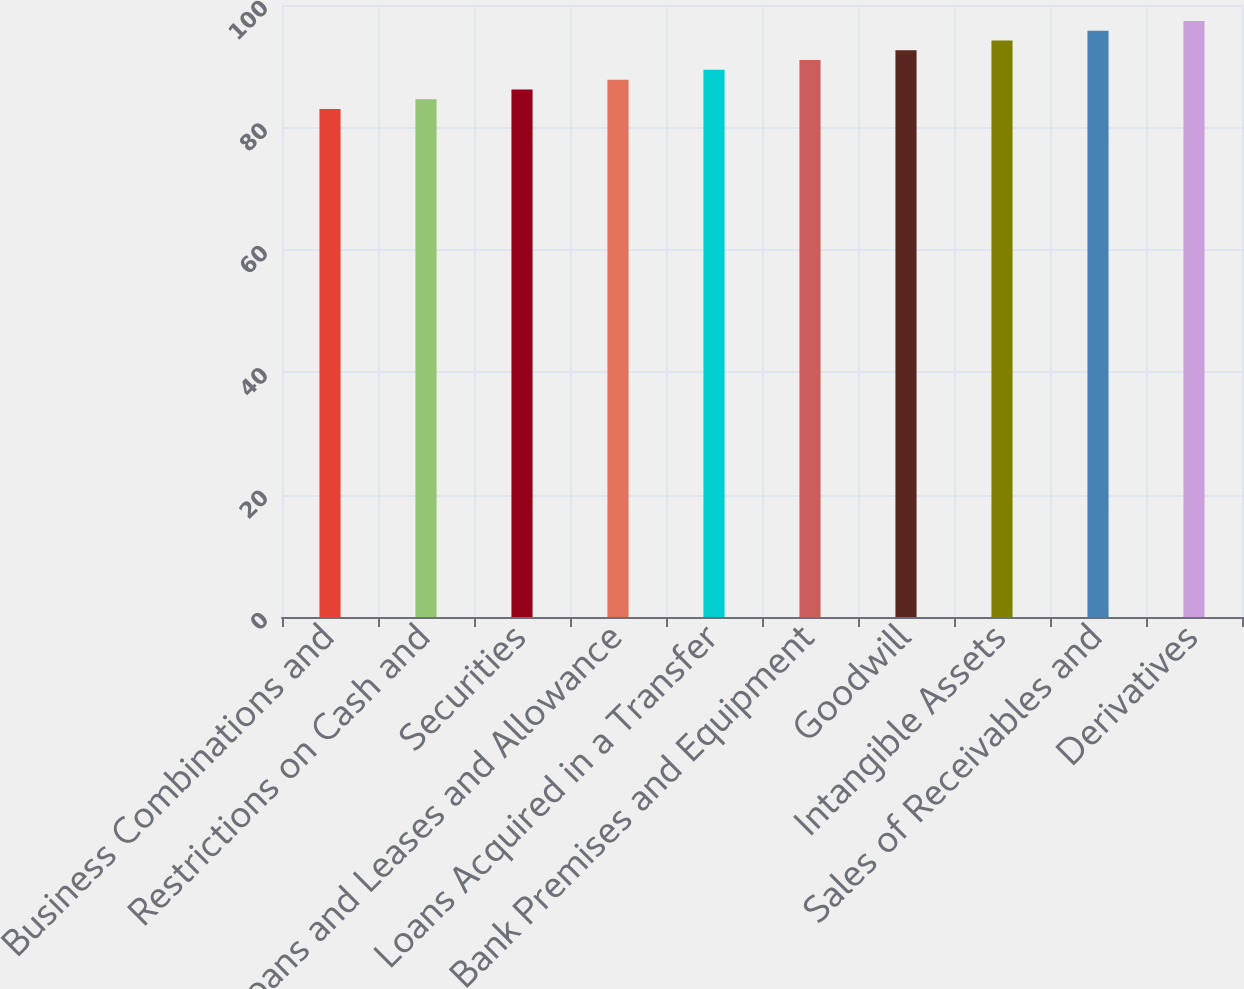<chart> <loc_0><loc_0><loc_500><loc_500><bar_chart><fcel>Business Combinations and<fcel>Restrictions on Cash and<fcel>Securities<fcel>Loans and Leases and Allowance<fcel>Loans Acquired in a Transfer<fcel>Bank Premises and Equipment<fcel>Goodwill<fcel>Intangible Assets<fcel>Sales of Receivables and<fcel>Derivatives<nl><fcel>83<fcel>84.6<fcel>86.2<fcel>87.8<fcel>89.4<fcel>91<fcel>92.6<fcel>94.2<fcel>95.8<fcel>97.4<nl></chart> 